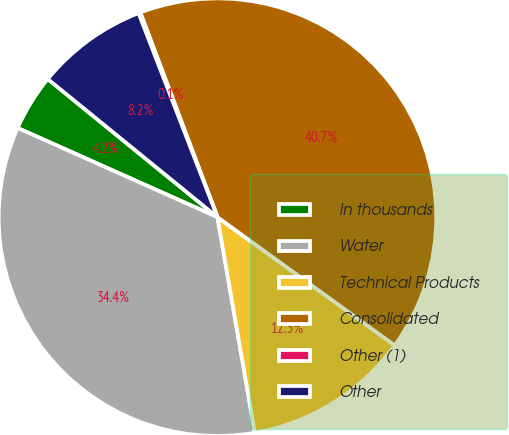Convert chart. <chart><loc_0><loc_0><loc_500><loc_500><pie_chart><fcel>In thousands<fcel>Water<fcel>Technical Products<fcel>Consolidated<fcel>Other (1)<fcel>Other<nl><fcel>4.19%<fcel>34.42%<fcel>12.3%<fcel>40.7%<fcel>0.14%<fcel>8.25%<nl></chart> 